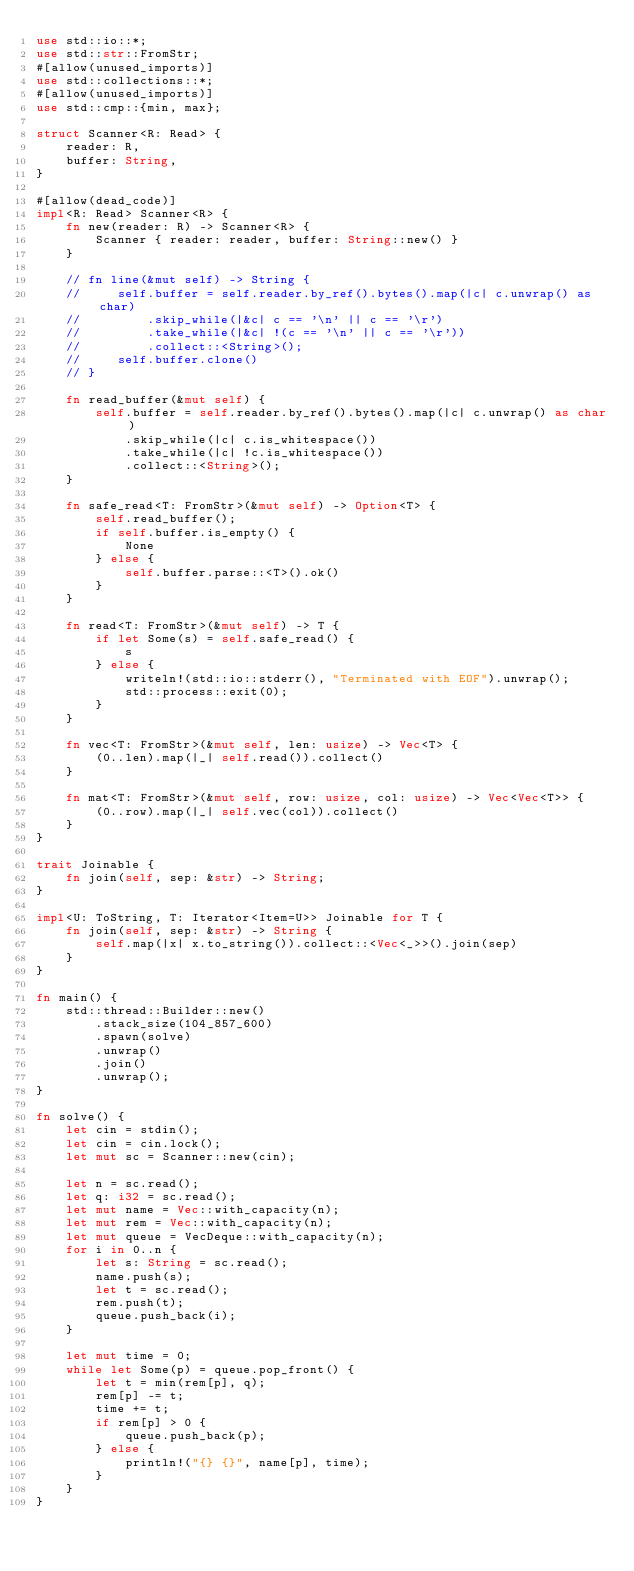<code> <loc_0><loc_0><loc_500><loc_500><_Rust_>use std::io::*;
use std::str::FromStr;
#[allow(unused_imports)]
use std::collections::*;
#[allow(unused_imports)]
use std::cmp::{min, max};

struct Scanner<R: Read> {
    reader: R,
    buffer: String,
}

#[allow(dead_code)]
impl<R: Read> Scanner<R> {
    fn new(reader: R) -> Scanner<R> {
        Scanner { reader: reader, buffer: String::new() }
    }

    // fn line(&mut self) -> String {
    //     self.buffer = self.reader.by_ref().bytes().map(|c| c.unwrap() as char)
    //         .skip_while(|&c| c == '\n' || c == '\r')
    //         .take_while(|&c| !(c == '\n' || c == '\r'))
    //         .collect::<String>();
    //     self.buffer.clone()
    // }

    fn read_buffer(&mut self) {
        self.buffer = self.reader.by_ref().bytes().map(|c| c.unwrap() as char)
            .skip_while(|c| c.is_whitespace())
            .take_while(|c| !c.is_whitespace())
            .collect::<String>();
    }

    fn safe_read<T: FromStr>(&mut self) -> Option<T> {
        self.read_buffer();
        if self.buffer.is_empty() {
            None
        } else {
            self.buffer.parse::<T>().ok()
        }
    }

    fn read<T: FromStr>(&mut self) -> T {
        if let Some(s) = self.safe_read() {
            s
        } else {
            writeln!(std::io::stderr(), "Terminated with EOF").unwrap();
            std::process::exit(0);
        }
    }

    fn vec<T: FromStr>(&mut self, len: usize) -> Vec<T> {
        (0..len).map(|_| self.read()).collect()
    }

    fn mat<T: FromStr>(&mut self, row: usize, col: usize) -> Vec<Vec<T>> {
        (0..row).map(|_| self.vec(col)).collect()
    }
}

trait Joinable {
    fn join(self, sep: &str) -> String;
}

impl<U: ToString, T: Iterator<Item=U>> Joinable for T {
    fn join(self, sep: &str) -> String {
        self.map(|x| x.to_string()).collect::<Vec<_>>().join(sep)
    }
}

fn main() {
    std::thread::Builder::new()
        .stack_size(104_857_600)
        .spawn(solve)
        .unwrap()
        .join()
        .unwrap();
}

fn solve() {
    let cin = stdin();
    let cin = cin.lock();
    let mut sc = Scanner::new(cin);

    let n = sc.read();
    let q: i32 = sc.read();
    let mut name = Vec::with_capacity(n);
    let mut rem = Vec::with_capacity(n);
    let mut queue = VecDeque::with_capacity(n);
    for i in 0..n {
        let s: String = sc.read();
        name.push(s);
        let t = sc.read();
        rem.push(t);
        queue.push_back(i);
    }

    let mut time = 0;
    while let Some(p) = queue.pop_front() {
        let t = min(rem[p], q);
        rem[p] -= t;
        time += t;
        if rem[p] > 0 {
            queue.push_back(p);
        } else {
            println!("{} {}", name[p], time);
        }
    }
}

</code> 